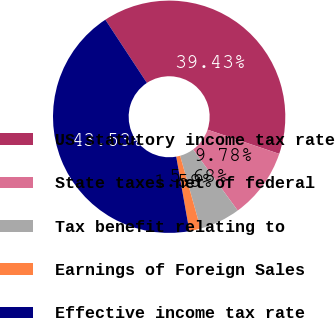<chart> <loc_0><loc_0><loc_500><loc_500><pie_chart><fcel>US statutory income tax rate<fcel>State taxes net of federal<fcel>Tax benefit relating to<fcel>Earnings of Foreign Sales<fcel>Effective income tax rate<nl><fcel>39.43%<fcel>9.78%<fcel>5.68%<fcel>1.58%<fcel>43.53%<nl></chart> 